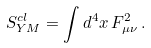<formula> <loc_0><loc_0><loc_500><loc_500>S _ { Y M } ^ { c l } = \int d ^ { 4 } x \, F ^ { 2 } _ { \mu \nu } \, .</formula> 